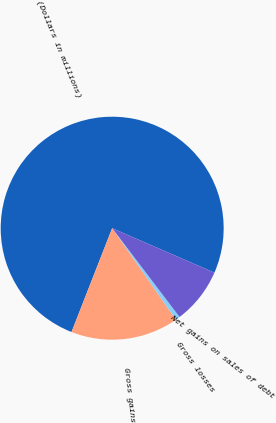Convert chart to OTSL. <chart><loc_0><loc_0><loc_500><loc_500><pie_chart><fcel>(Dollars in millions)<fcel>Gross gains<fcel>Gross losses<fcel>Net gains on sales of debt<nl><fcel>75.59%<fcel>15.63%<fcel>0.64%<fcel>8.14%<nl></chart> 